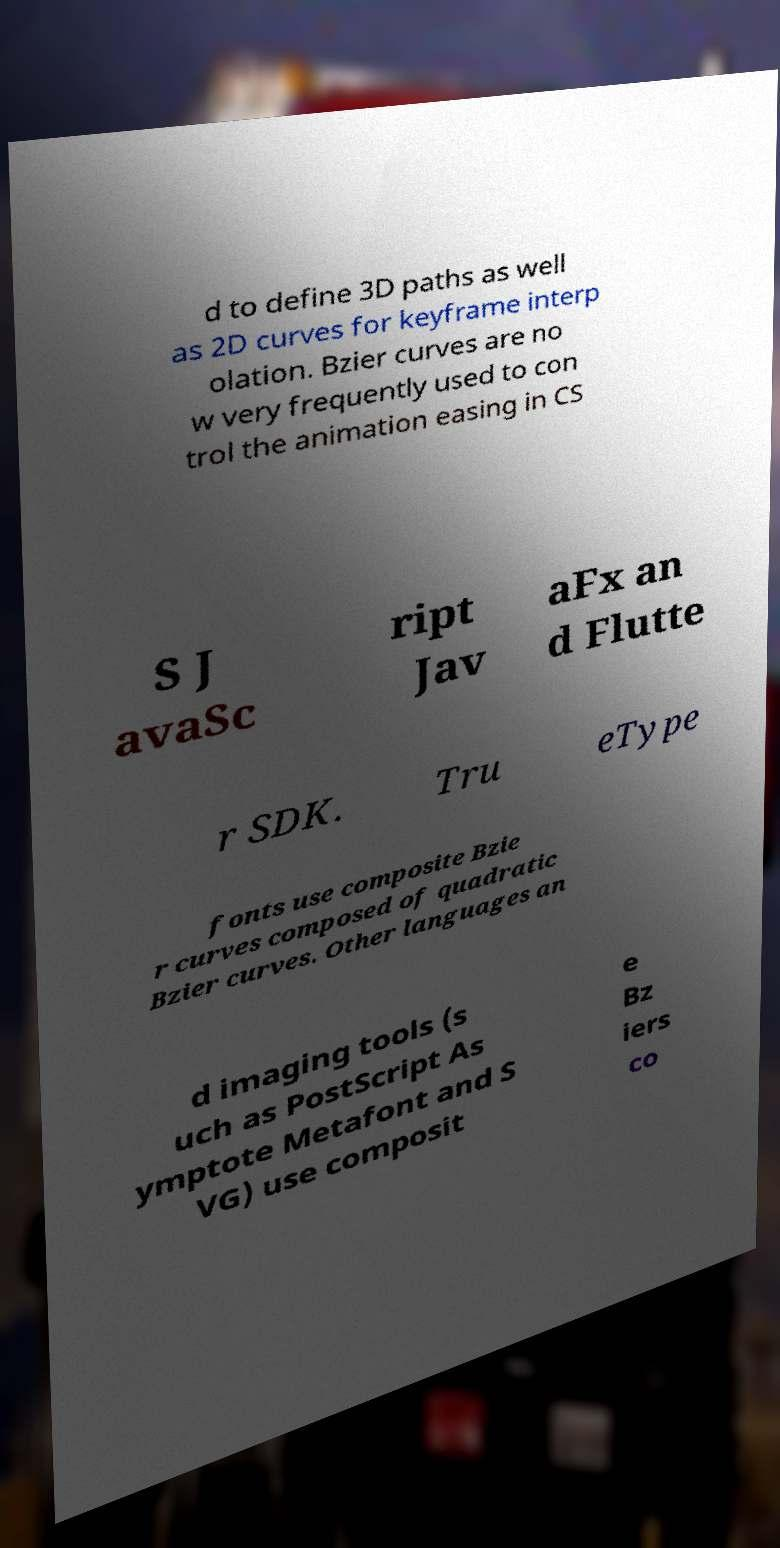Can you read and provide the text displayed in the image?This photo seems to have some interesting text. Can you extract and type it out for me? d to define 3D paths as well as 2D curves for keyframe interp olation. Bzier curves are no w very frequently used to con trol the animation easing in CS S J avaSc ript Jav aFx an d Flutte r SDK. Tru eType fonts use composite Bzie r curves composed of quadratic Bzier curves. Other languages an d imaging tools (s uch as PostScript As ymptote Metafont and S VG) use composit e Bz iers co 